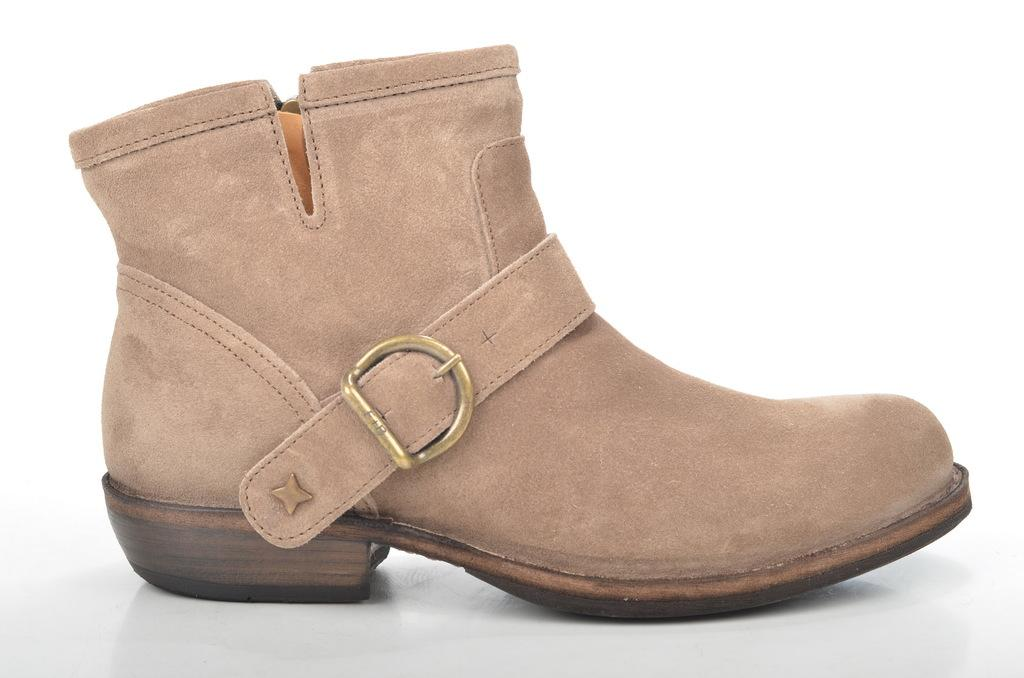What is the main subject of the image? There is a boot in the center of the image. Where is the sink located in the image? There is no sink present in the image; it only features a boot. Is the person wearing the boot in the image sleeping? The image does not show a person wearing the boot, nor does it depict anyone sleeping. 